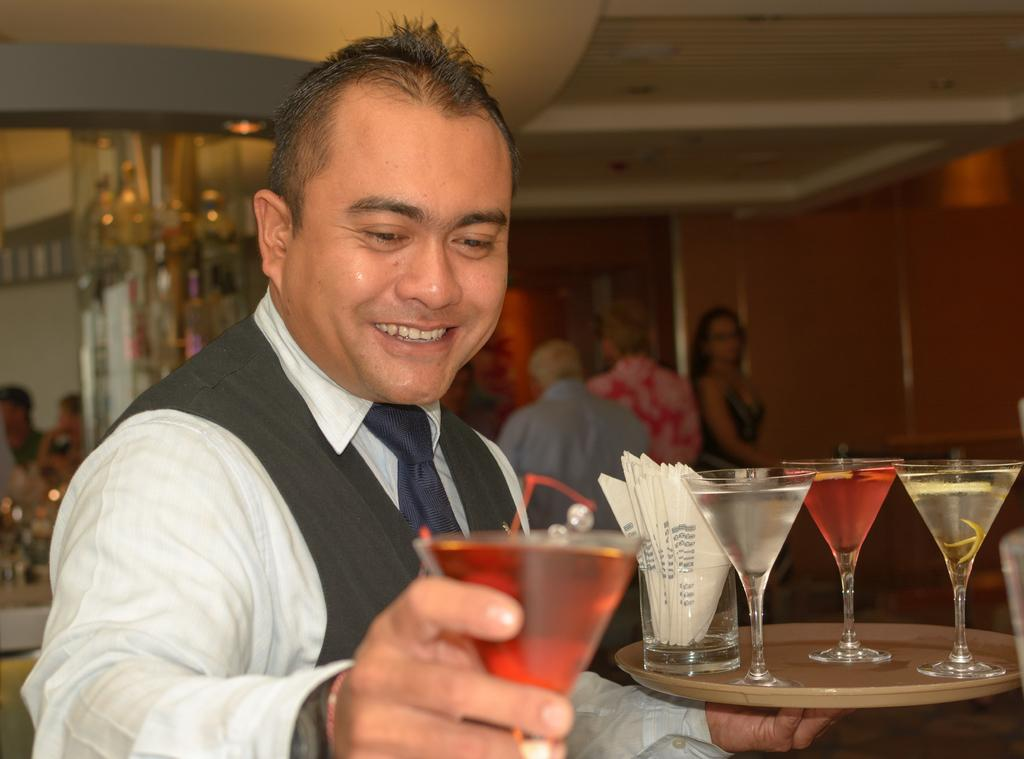What is the man in the image holding? The man is holding a glass with a drink in it. What are the other people in the image doing? There are persons standing and sitting in the image. What can be seen in the background of the image? There is a wall and a ceiling in the image. Reasoning: Let's think step by identifying the main subjects and objects in the image based on the provided facts. We then formulate questions that focus on the actions and positions of the people, as well as the background elements. We ensure that each question can be answered definitively with the information given, and we avoid yes/no questions and use simple and clear language. Absurd Question/Answer: What type of glove is the man wearing in the image? There is no glove present in the image; the man is holding a glass with a drink in it. What type of curve can be seen in the image? There is no curve present in the image; the image features a man holding a glass with a drink in it, other people standing and sitting, and a wall and ceiling in the background. 